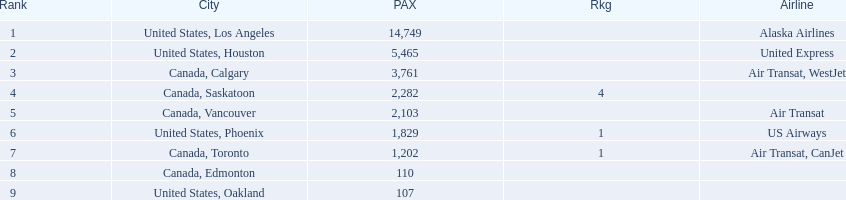What were all the passenger totals? 14,749, 5,465, 3,761, 2,282, 2,103, 1,829, 1,202, 110, 107. Which of these were to los angeles? 14,749. What other destination combined with this is closest to 19,000? Canada, Calgary. 